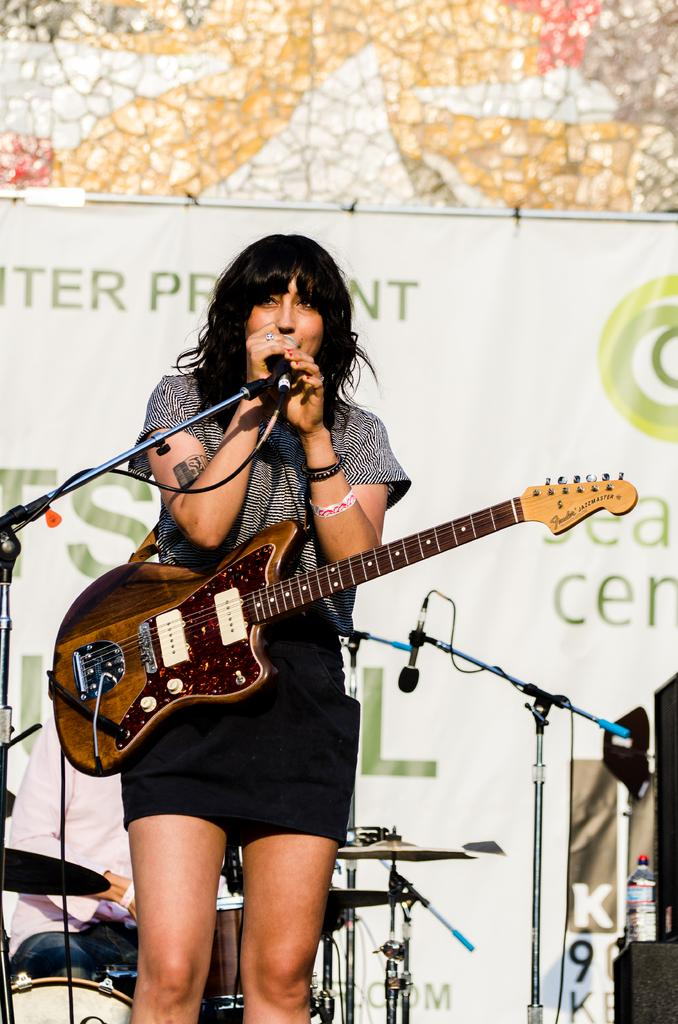Who is the main subject in the image? There is a woman in the image. What is the woman holding in the image? The woman is holding a guitar. What is the woman doing with the microphone in her hand? The woman is singing with a microphone in her hand. What other musical instrument can be seen in the image? There are drums visible in the image. What additional element is present in the image? There is a banner present in the image. How many boats are visible in the image? There are no boats present in the image. What type of cattle can be seen grazing in the background of the image? There is no cattle present in the image; it features a woman playing a guitar and singing with a microphone and drums visible. 